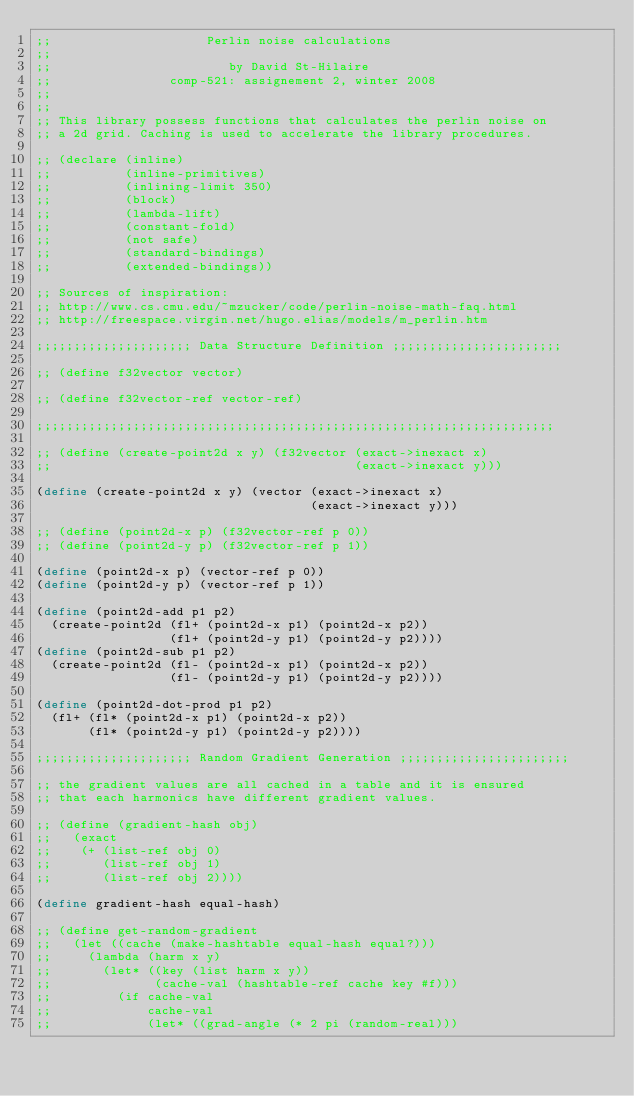<code> <loc_0><loc_0><loc_500><loc_500><_Scheme_>;;                     Perlin noise calculations
;;                     
;;                        by David St-Hilaire
;;                comp-521: assignement 2, winter 2008
;;
;;
;; This library possess functions that calculates the perlin noise on
;; a 2d grid. Caching is used to accelerate the library procedures.

;; (declare (inline)
;;          (inline-primitives)
;;          (inlining-limit 350)
;;          (block)
;;          (lambda-lift)
;;          (constant-fold)
;;          (not safe)
;;          (standard-bindings)
;;          (extended-bindings))

;; Sources of inspiration:
;; http://www.cs.cmu.edu/~mzucker/code/perlin-noise-math-faq.html
;; http://freespace.virgin.net/hugo.elias/models/m_perlin.htm

;;;;;;;;;;;;;;;;;;;;; Data Structure Definition ;;;;;;;;;;;;;;;;;;;;;;;

;; (define f32vector vector)

;; (define f32vector-ref vector-ref)

;;;;;;;;;;;;;;;;;;;;;;;;;;;;;;;;;;;;;;;;;;;;;;;;;;;;;;;;;;;;;;;;;;;;;;

;; (define (create-point2d x y) (f32vector (exact->inexact x)
;;                                         (exact->inexact y)))

(define (create-point2d x y) (vector (exact->inexact x)
                                     (exact->inexact y)))

;; (define (point2d-x p) (f32vector-ref p 0))
;; (define (point2d-y p) (f32vector-ref p 1))

(define (point2d-x p) (vector-ref p 0))
(define (point2d-y p) (vector-ref p 1))

(define (point2d-add p1 p2)
  (create-point2d (fl+ (point2d-x p1) (point2d-x p2))
                  (fl+ (point2d-y p1) (point2d-y p2))))
(define (point2d-sub p1 p2)
  (create-point2d (fl- (point2d-x p1) (point2d-x p2))
                  (fl- (point2d-y p1) (point2d-y p2))))

(define (point2d-dot-prod p1 p2)
  (fl+ (fl* (point2d-x p1) (point2d-x p2))
       (fl* (point2d-y p1) (point2d-y p2))))

;;;;;;;;;;;;;;;;;;;;; Random Gradient Generation ;;;;;;;;;;;;;;;;;;;;;;;

;; the gradient values are all cached in a table and it is ensured
;; that each harmonics have different gradient values.

;; (define (gradient-hash obj)
;;   (exact
;;    (+ (list-ref obj 0)
;;       (list-ref obj 1)
;;       (list-ref obj 2))))

(define gradient-hash equal-hash)

;; (define get-random-gradient
;;   (let ((cache (make-hashtable equal-hash equal?)))
;;     (lambda (harm x y)
;;       (let* ((key (list harm x y))
;;              (cache-val (hashtable-ref cache key #f)))
;;         (if cache-val
;;             cache-val
;;             (let* ((grad-angle (* 2 pi (random-real)))</code> 